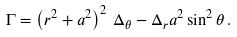Convert formula to latex. <formula><loc_0><loc_0><loc_500><loc_500>\Gamma = \left ( r ^ { 2 } + a ^ { 2 } \right ) ^ { 2 } \, \Delta _ { \theta } - \Delta _ { r } a ^ { 2 } \sin ^ { 2 } \theta \, .</formula> 